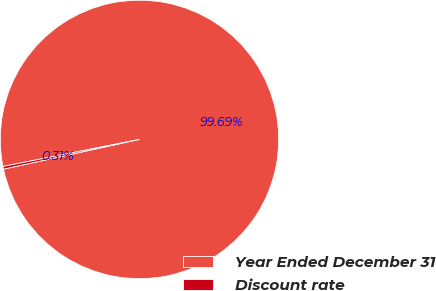Convert chart. <chart><loc_0><loc_0><loc_500><loc_500><pie_chart><fcel>Year Ended December 31<fcel>Discount rate<nl><fcel>99.69%<fcel>0.31%<nl></chart> 